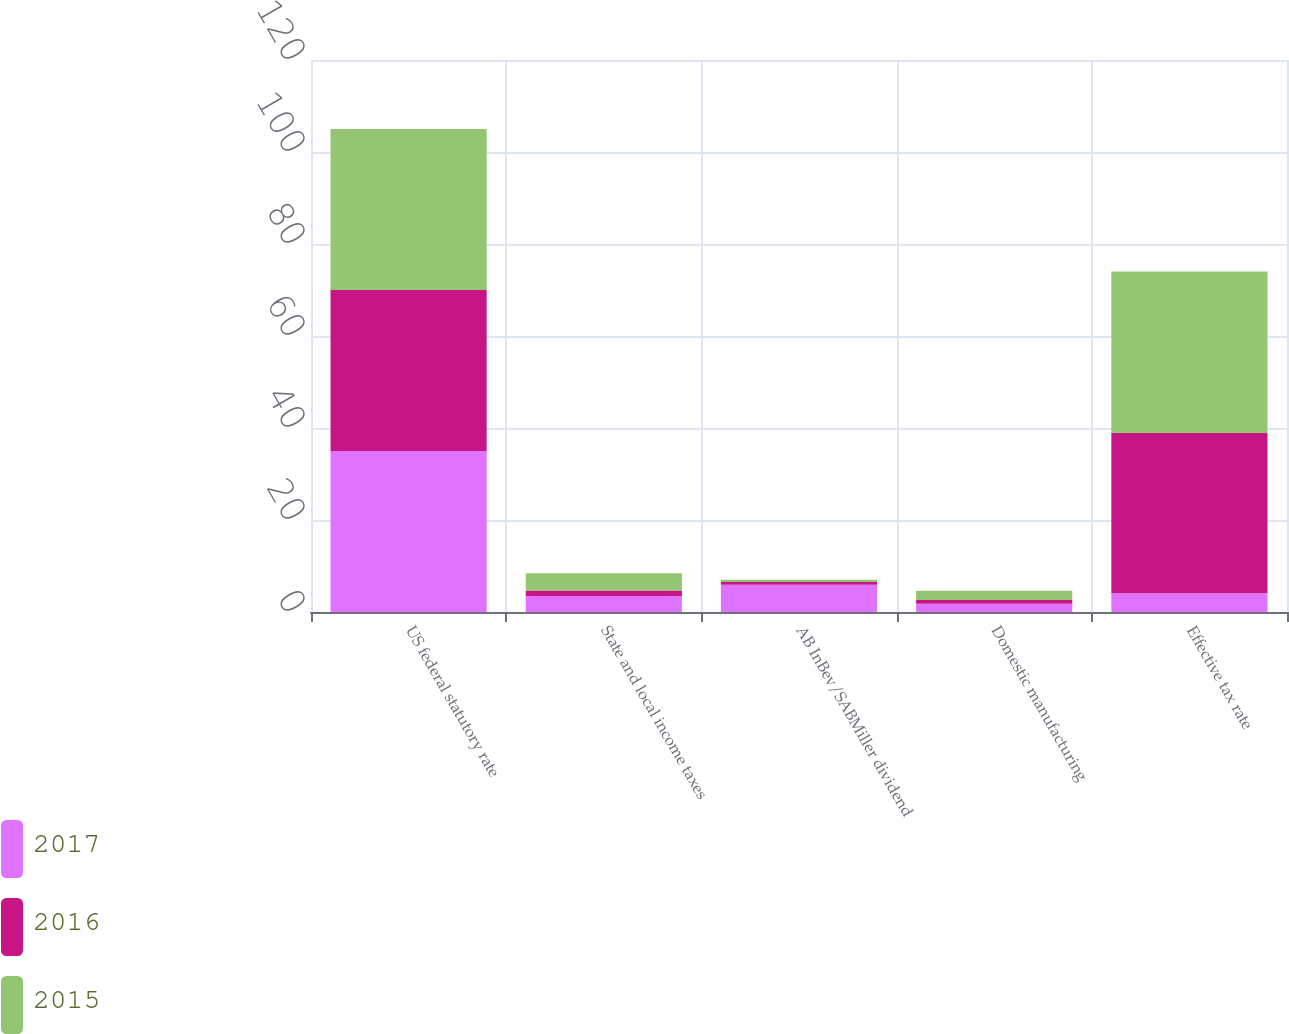<chart> <loc_0><loc_0><loc_500><loc_500><stacked_bar_chart><ecel><fcel>US federal statutory rate<fcel>State and local income taxes<fcel>AB InBev/SABMiller dividend<fcel>Domestic manufacturing<fcel>Effective tax rate<nl><fcel>2017<fcel>35<fcel>3.5<fcel>5.9<fcel>1.8<fcel>4.1<nl><fcel>2016<fcel>35<fcel>1.2<fcel>0.6<fcel>0.8<fcel>34.8<nl><fcel>2015<fcel>35<fcel>3.7<fcel>0.5<fcel>2<fcel>35.1<nl></chart> 